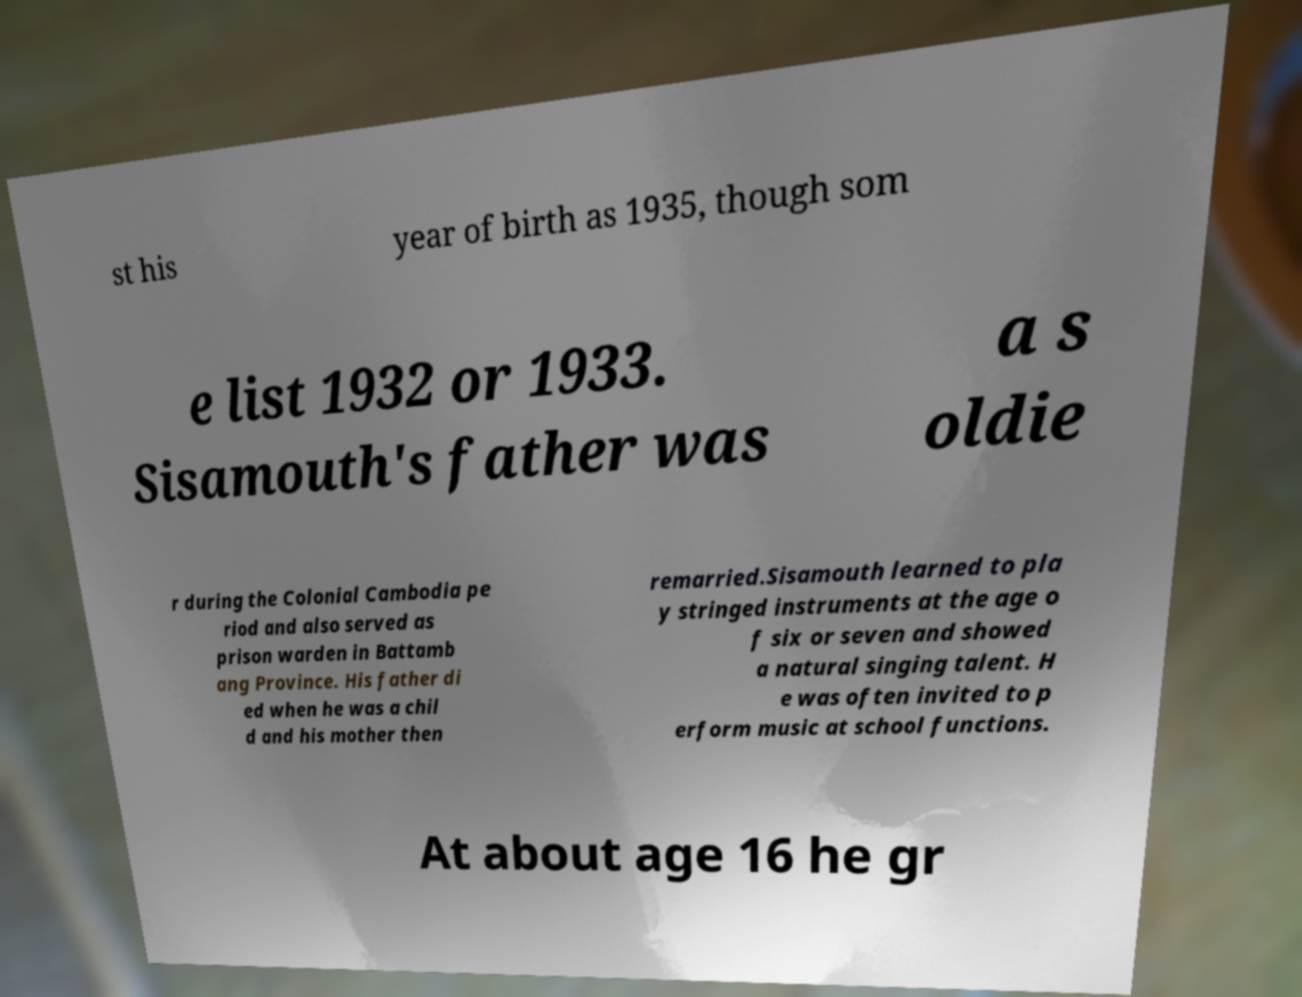Please identify and transcribe the text found in this image. st his year of birth as 1935, though som e list 1932 or 1933. Sisamouth's father was a s oldie r during the Colonial Cambodia pe riod and also served as prison warden in Battamb ang Province. His father di ed when he was a chil d and his mother then remarried.Sisamouth learned to pla y stringed instruments at the age o f six or seven and showed a natural singing talent. H e was often invited to p erform music at school functions. At about age 16 he gr 